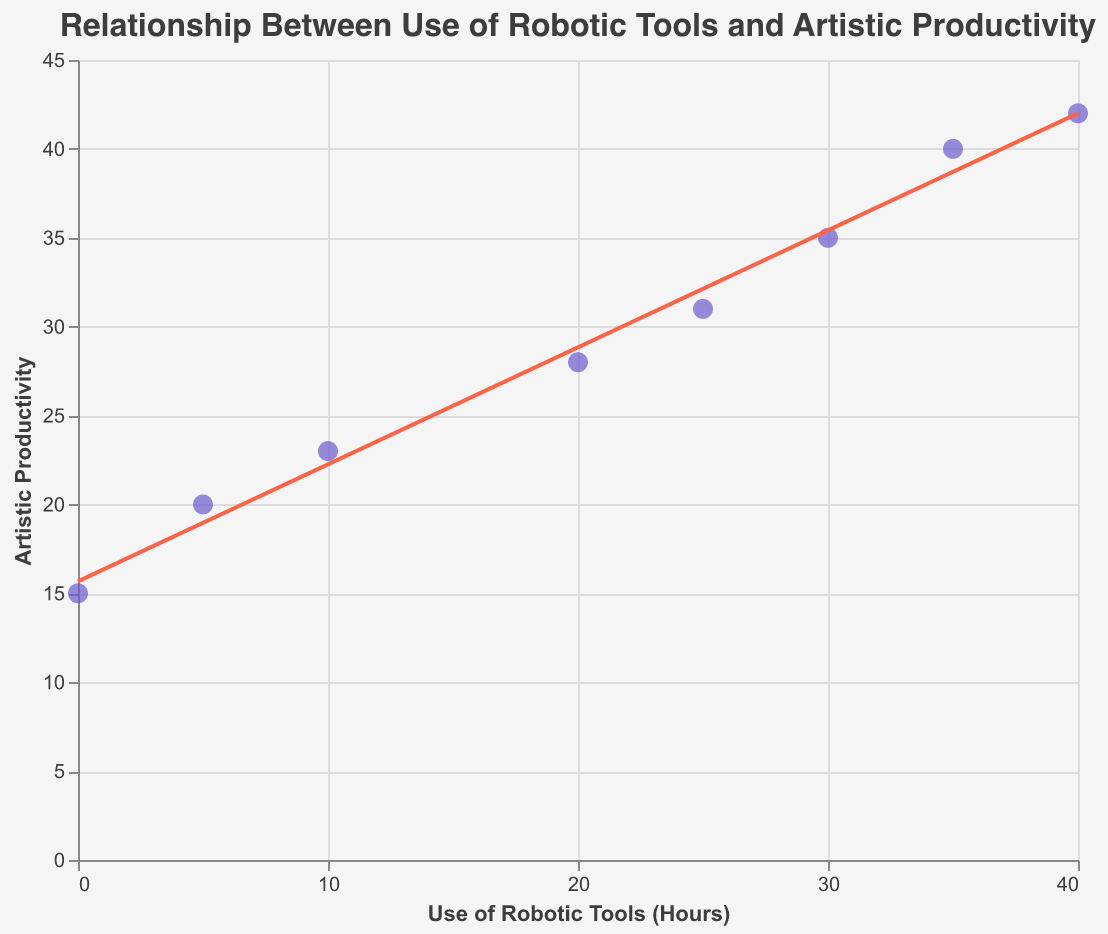What is the title of the figure? The figure's title is located at the top and reads "Relationship Between Use of Robotic Tools and Artistic Productivity".
Answer: Relationship Between Use of Robotic Tools and Artistic Productivity How many data points are shown in the scatter plot? The scatter plot includes data points for each year from 2015 to 2022. Counting these, there are 8 data points plotted.
Answer: 8 What is the y-axis title? The y-axis title is "Artistic Productivity", which is clearly labeled along the vertical axis.
Answer: Artistic Productivity What trend can be observed from the scatter plot with the trend line? Observing the scatter plot, the trend line shows a positive trend, indicating that as the use of robotic tools increases, artistic productivity also tends to increase.
Answer: Positive trend What was the artistic productivity in 2020? By looking at the data point for the year 2020, the y-coordinate shows that artistic productivity is 35.
Answer: 35 By how much did the use of robotic tools increase between 2016 and 2021? In 2016, the use of robotic tools was 5 hours, and in 2021, it was 35 hours. The increase is calculated as 35 - 5 = 30 hours.
Answer: 30 hours Between which years did the most significant increase in artistic productivity occur? Comparing the artistic productivity between consecutive years, the most significant increase occurs between 2020 (35) and 2021 (40), which is an increase of 5 units.
Answer: 2020 to 2021 In which year was there no use of robotic tools? The scatter plot shows that in 2015, the use of robotic tools was zero hours.
Answer: 2015 What is the general relationship conveyed by the trend line? The trend line generally indicates that there is a strong positive linear relationship between the hours of robotic tools used and artistic productivity.
Answer: Positive linear relationship 